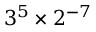<formula> <loc_0><loc_0><loc_500><loc_500>3 ^ { 5 } \times 2 ^ { - 7 }</formula> 